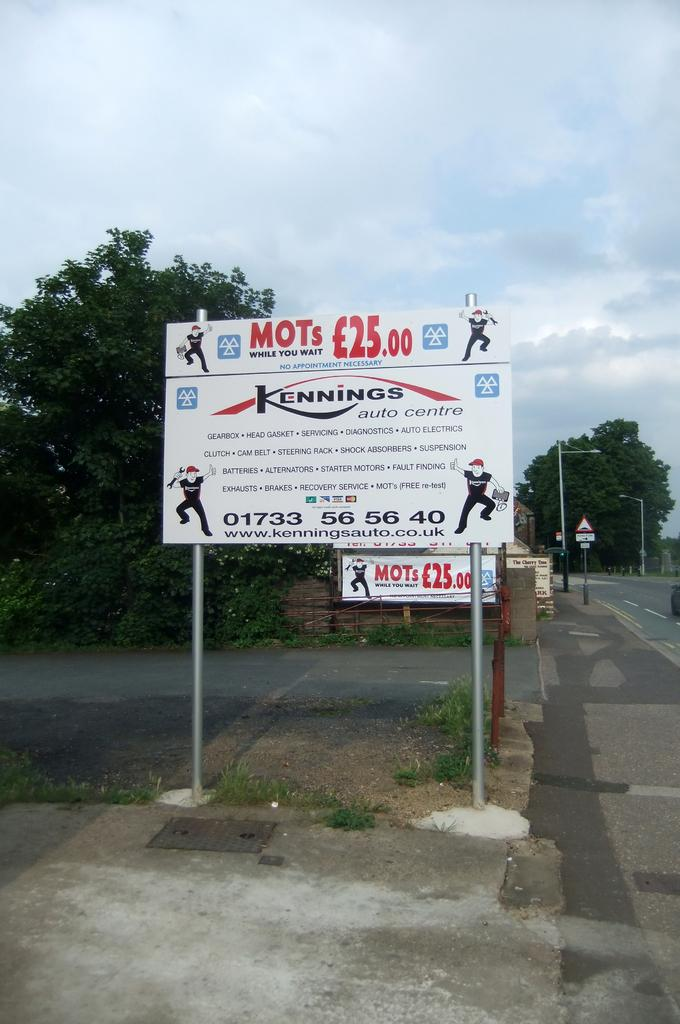Provide a one-sentence caption for the provided image. Large sign on two metal poles that read "MOTs While you wait". 